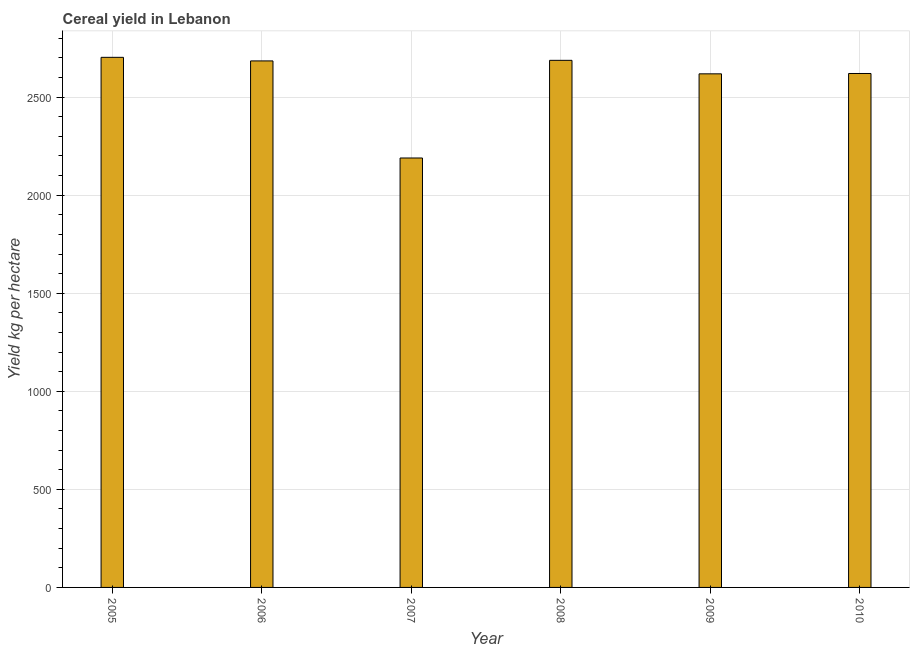What is the title of the graph?
Your answer should be compact. Cereal yield in Lebanon. What is the label or title of the X-axis?
Keep it short and to the point. Year. What is the label or title of the Y-axis?
Your answer should be compact. Yield kg per hectare. What is the cereal yield in 2009?
Ensure brevity in your answer.  2618.89. Across all years, what is the maximum cereal yield?
Your answer should be very brief. 2703.07. Across all years, what is the minimum cereal yield?
Offer a very short reply. 2189.75. In which year was the cereal yield maximum?
Keep it short and to the point. 2005. What is the sum of the cereal yield?
Provide a short and direct response. 1.55e+04. What is the difference between the cereal yield in 2007 and 2009?
Give a very brief answer. -429.14. What is the average cereal yield per year?
Offer a very short reply. 2584.15. What is the median cereal yield?
Your answer should be compact. 2652.74. Is the cereal yield in 2009 less than that in 2010?
Offer a terse response. Yes. Is the difference between the cereal yield in 2005 and 2009 greater than the difference between any two years?
Provide a short and direct response. No. What is the difference between the highest and the second highest cereal yield?
Keep it short and to the point. 15.34. Is the sum of the cereal yield in 2005 and 2009 greater than the maximum cereal yield across all years?
Provide a short and direct response. Yes. What is the difference between the highest and the lowest cereal yield?
Ensure brevity in your answer.  513.32. How many bars are there?
Your response must be concise. 6. Are the values on the major ticks of Y-axis written in scientific E-notation?
Give a very brief answer. No. What is the Yield kg per hectare of 2005?
Keep it short and to the point. 2703.07. What is the Yield kg per hectare in 2006?
Your response must be concise. 2684.81. What is the Yield kg per hectare of 2007?
Provide a succinct answer. 2189.75. What is the Yield kg per hectare of 2008?
Your answer should be very brief. 2687.72. What is the Yield kg per hectare of 2009?
Offer a very short reply. 2618.89. What is the Yield kg per hectare in 2010?
Make the answer very short. 2620.67. What is the difference between the Yield kg per hectare in 2005 and 2006?
Ensure brevity in your answer.  18.25. What is the difference between the Yield kg per hectare in 2005 and 2007?
Provide a short and direct response. 513.32. What is the difference between the Yield kg per hectare in 2005 and 2008?
Your response must be concise. 15.34. What is the difference between the Yield kg per hectare in 2005 and 2009?
Your answer should be compact. 84.18. What is the difference between the Yield kg per hectare in 2005 and 2010?
Keep it short and to the point. 82.39. What is the difference between the Yield kg per hectare in 2006 and 2007?
Your answer should be compact. 495.06. What is the difference between the Yield kg per hectare in 2006 and 2008?
Make the answer very short. -2.91. What is the difference between the Yield kg per hectare in 2006 and 2009?
Provide a short and direct response. 65.92. What is the difference between the Yield kg per hectare in 2006 and 2010?
Offer a terse response. 64.14. What is the difference between the Yield kg per hectare in 2007 and 2008?
Provide a short and direct response. -497.97. What is the difference between the Yield kg per hectare in 2007 and 2009?
Ensure brevity in your answer.  -429.14. What is the difference between the Yield kg per hectare in 2007 and 2010?
Your response must be concise. -430.92. What is the difference between the Yield kg per hectare in 2008 and 2009?
Your answer should be compact. 68.84. What is the difference between the Yield kg per hectare in 2008 and 2010?
Your response must be concise. 67.05. What is the difference between the Yield kg per hectare in 2009 and 2010?
Keep it short and to the point. -1.79. What is the ratio of the Yield kg per hectare in 2005 to that in 2006?
Provide a short and direct response. 1.01. What is the ratio of the Yield kg per hectare in 2005 to that in 2007?
Provide a succinct answer. 1.23. What is the ratio of the Yield kg per hectare in 2005 to that in 2008?
Offer a very short reply. 1.01. What is the ratio of the Yield kg per hectare in 2005 to that in 2009?
Provide a short and direct response. 1.03. What is the ratio of the Yield kg per hectare in 2005 to that in 2010?
Your answer should be very brief. 1.03. What is the ratio of the Yield kg per hectare in 2006 to that in 2007?
Your response must be concise. 1.23. What is the ratio of the Yield kg per hectare in 2006 to that in 2008?
Your answer should be very brief. 1. What is the ratio of the Yield kg per hectare in 2006 to that in 2010?
Ensure brevity in your answer.  1.02. What is the ratio of the Yield kg per hectare in 2007 to that in 2008?
Keep it short and to the point. 0.81. What is the ratio of the Yield kg per hectare in 2007 to that in 2009?
Offer a very short reply. 0.84. What is the ratio of the Yield kg per hectare in 2007 to that in 2010?
Offer a terse response. 0.84. What is the ratio of the Yield kg per hectare in 2008 to that in 2009?
Your response must be concise. 1.03. What is the ratio of the Yield kg per hectare in 2009 to that in 2010?
Your answer should be very brief. 1. 